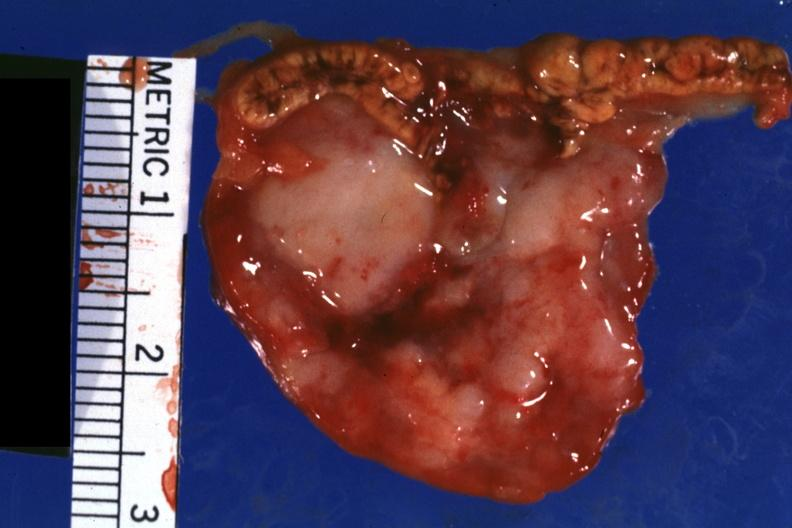s photo bloody?
Answer the question using a single word or phrase. Yes 